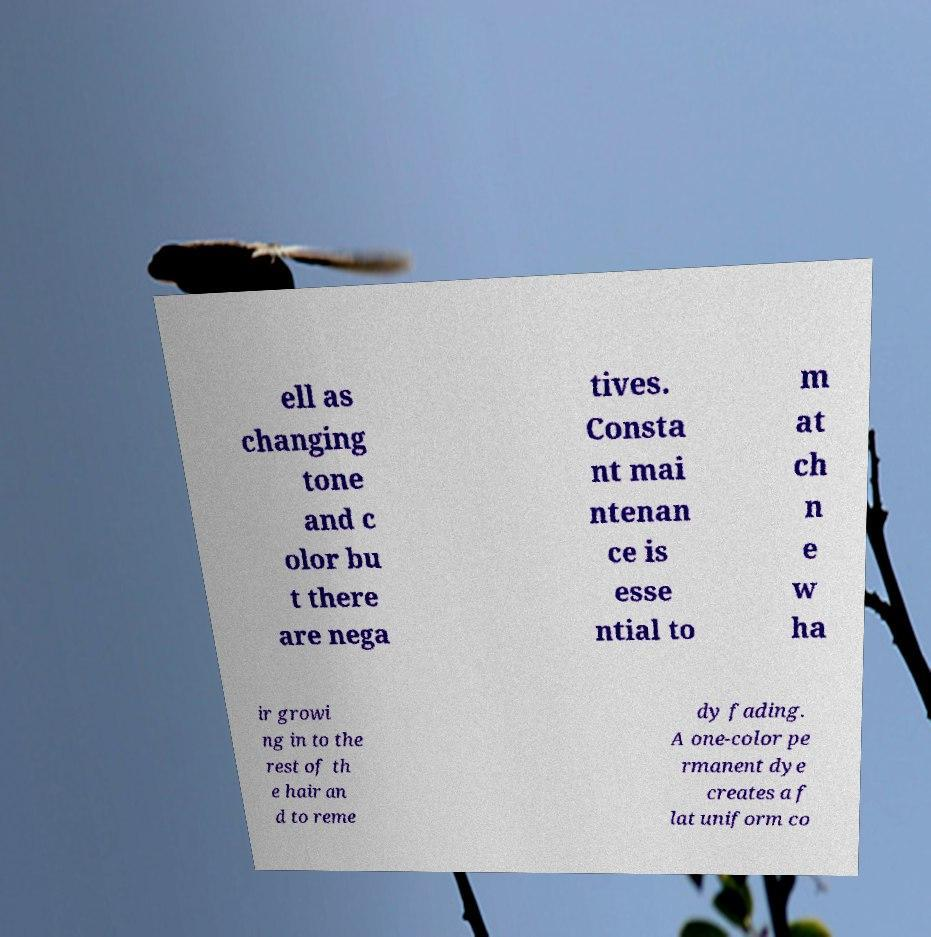There's text embedded in this image that I need extracted. Can you transcribe it verbatim? ell as changing tone and c olor bu t there are nega tives. Consta nt mai ntenan ce is esse ntial to m at ch n e w ha ir growi ng in to the rest of th e hair an d to reme dy fading. A one-color pe rmanent dye creates a f lat uniform co 